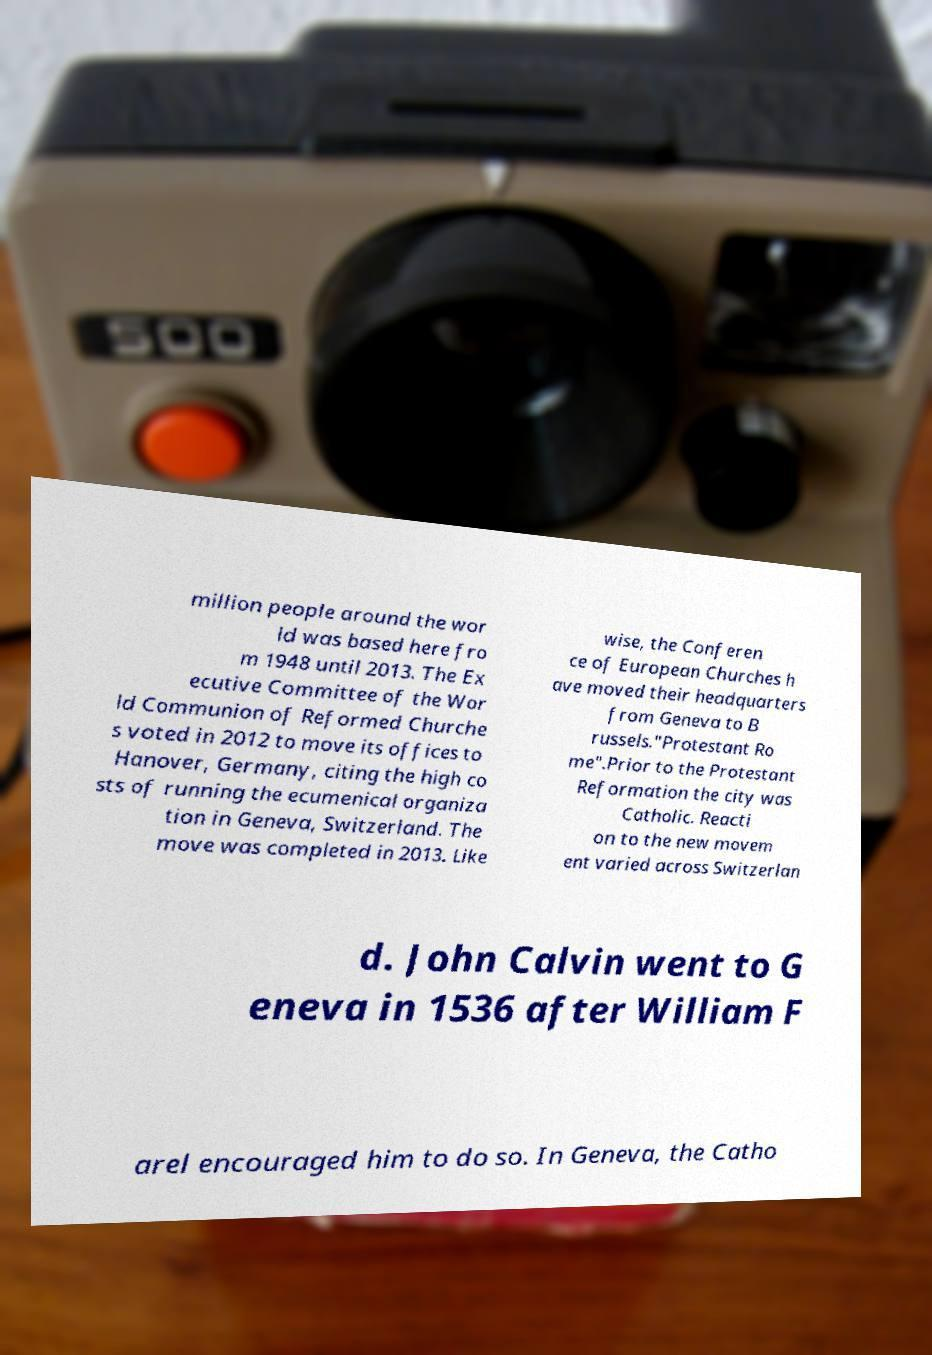What messages or text are displayed in this image? I need them in a readable, typed format. million people around the wor ld was based here fro m 1948 until 2013. The Ex ecutive Committee of the Wor ld Communion of Reformed Churche s voted in 2012 to move its offices to Hanover, Germany, citing the high co sts of running the ecumenical organiza tion in Geneva, Switzerland. The move was completed in 2013. Like wise, the Conferen ce of European Churches h ave moved their headquarters from Geneva to B russels."Protestant Ro me".Prior to the Protestant Reformation the city was Catholic. Reacti on to the new movem ent varied across Switzerlan d. John Calvin went to G eneva in 1536 after William F arel encouraged him to do so. In Geneva, the Catho 